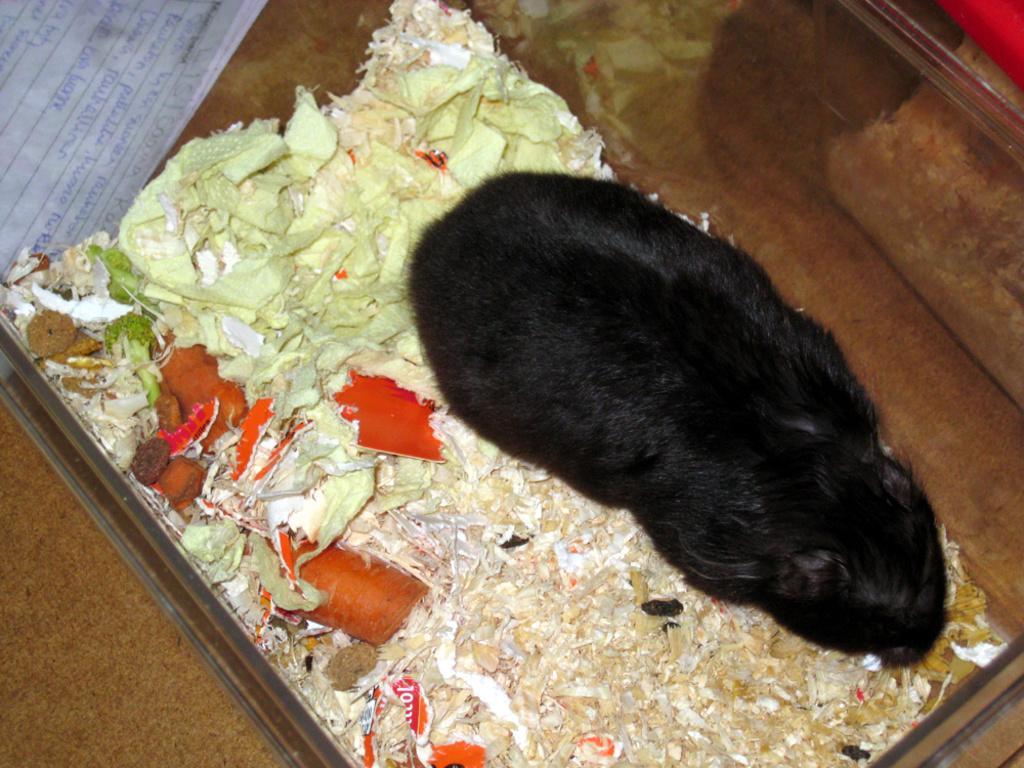Describe this image in one or two sentences. In this picture, it seems like a rabbit and vegetables on a tray in the foreground area of the image. There is a paper in the top left side. 